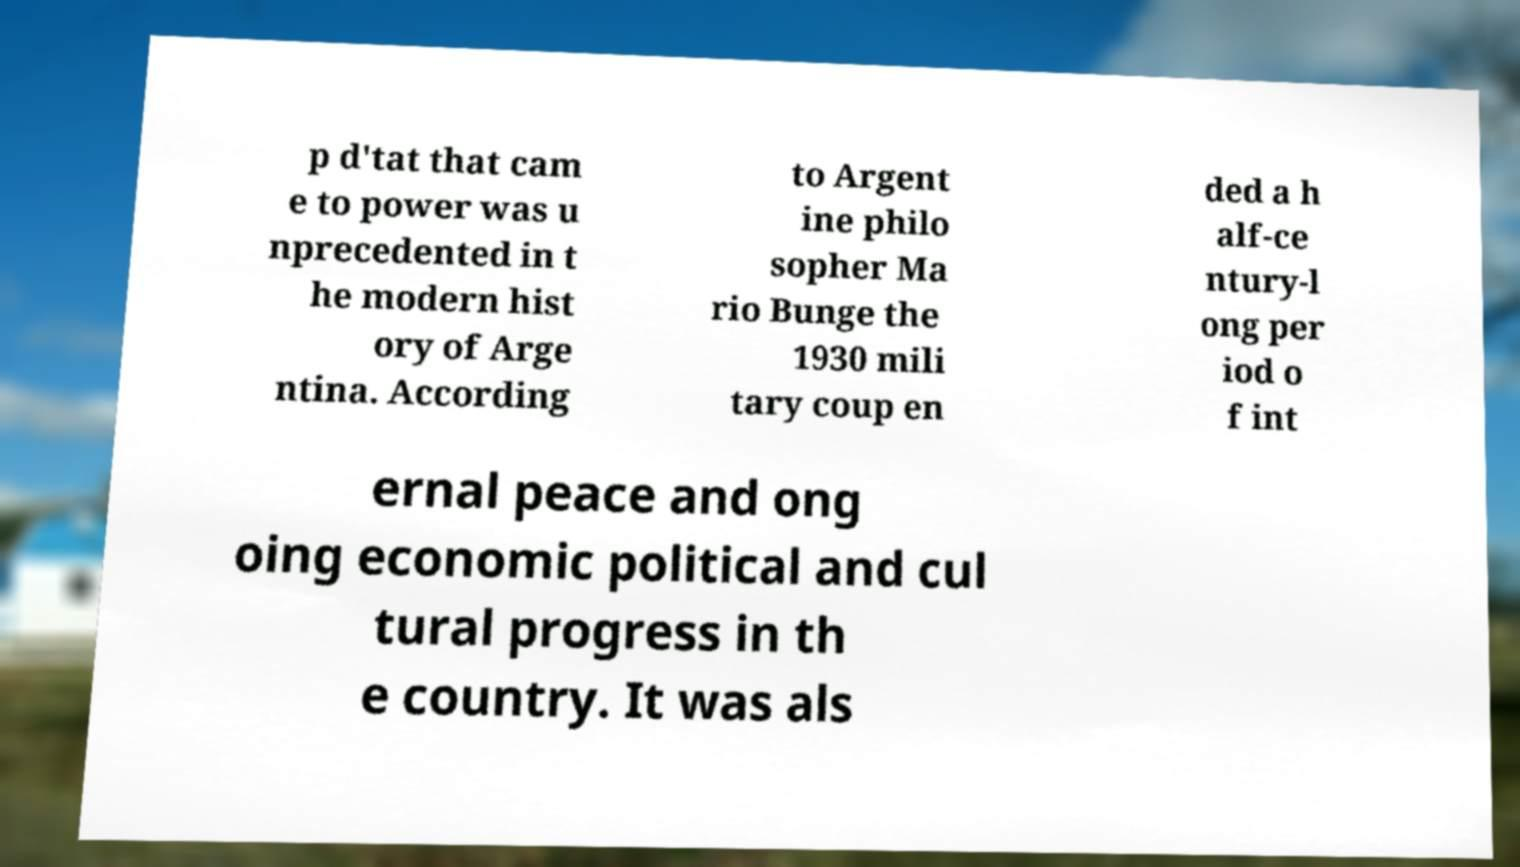There's text embedded in this image that I need extracted. Can you transcribe it verbatim? p d'tat that cam e to power was u nprecedented in t he modern hist ory of Arge ntina. According to Argent ine philo sopher Ma rio Bunge the 1930 mili tary coup en ded a h alf-ce ntury-l ong per iod o f int ernal peace and ong oing economic political and cul tural progress in th e country. It was als 